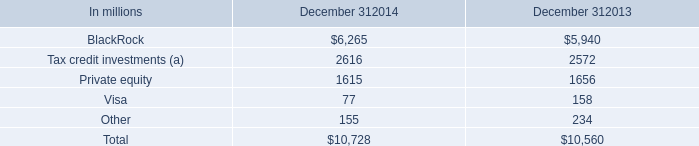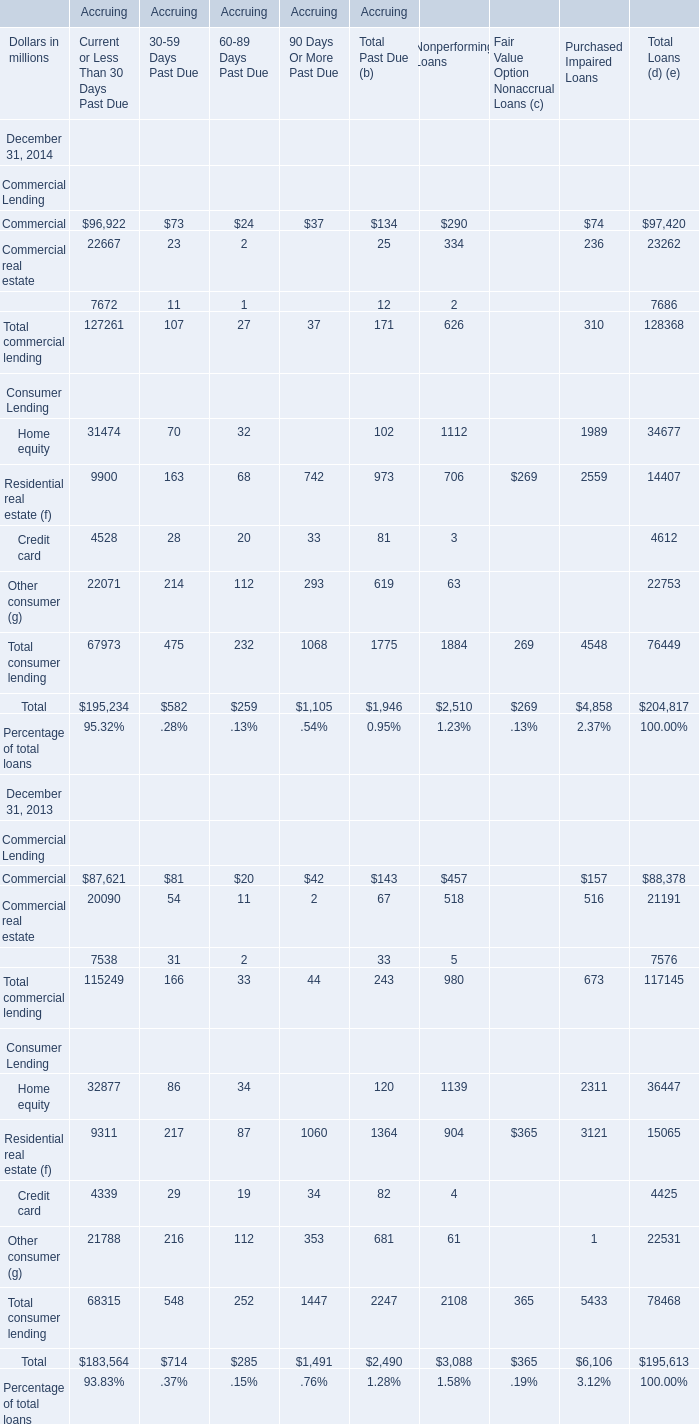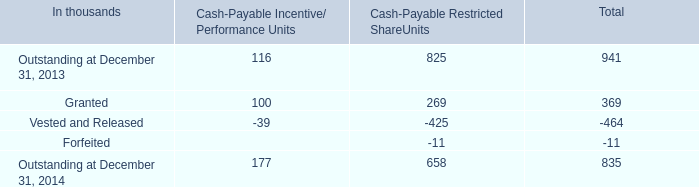for equity investment balances including unfunded commitments what was the change in millions between december 31 , 2014 and december 31 , 2013/ 
Computations: (717 - 802)
Answer: -85.0. 